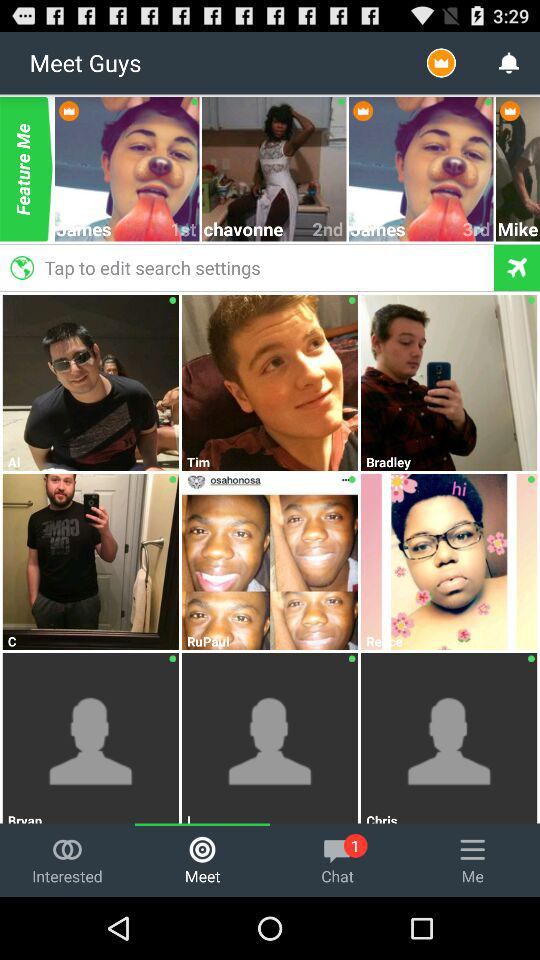Which tab am I using? You are using the "Meet" tab. 